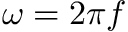Convert formula to latex. <formula><loc_0><loc_0><loc_500><loc_500>\omega = 2 \pi f</formula> 